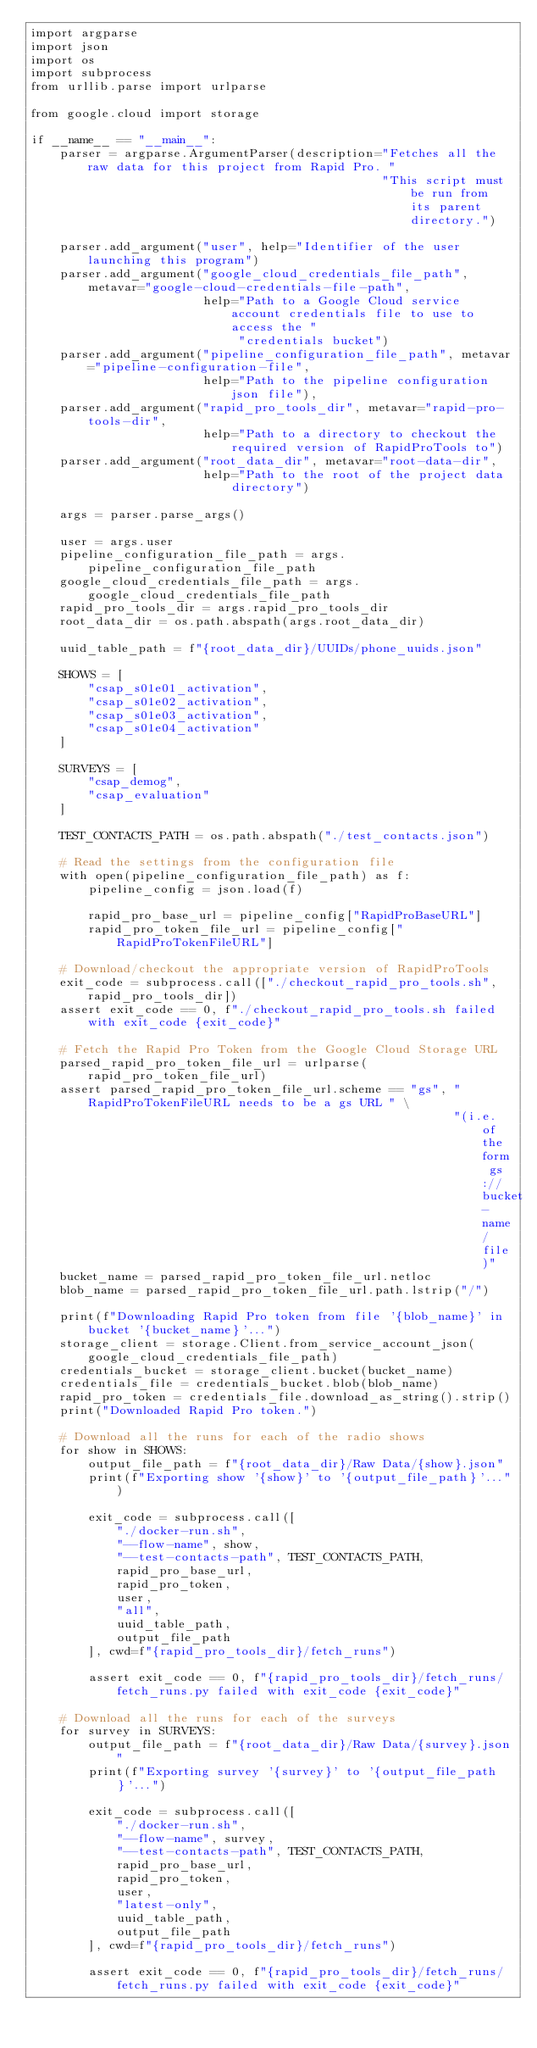Convert code to text. <code><loc_0><loc_0><loc_500><loc_500><_Python_>import argparse
import json
import os
import subprocess
from urllib.parse import urlparse

from google.cloud import storage

if __name__ == "__main__":
    parser = argparse.ArgumentParser(description="Fetches all the raw data for this project from Rapid Pro. "
                                                 "This script must be run from its parent directory.")

    parser.add_argument("user", help="Identifier of the user launching this program")
    parser.add_argument("google_cloud_credentials_file_path", metavar="google-cloud-credentials-file-path",
                        help="Path to a Google Cloud service account credentials file to use to access the "
                             "credentials bucket")
    parser.add_argument("pipeline_configuration_file_path", metavar="pipeline-configuration-file",
                        help="Path to the pipeline configuration json file"),
    parser.add_argument("rapid_pro_tools_dir", metavar="rapid-pro-tools-dir",
                        help="Path to a directory to checkout the required version of RapidProTools to")
    parser.add_argument("root_data_dir", metavar="root-data-dir",
                        help="Path to the root of the project data directory")

    args = parser.parse_args()

    user = args.user
    pipeline_configuration_file_path = args.pipeline_configuration_file_path
    google_cloud_credentials_file_path = args.google_cloud_credentials_file_path
    rapid_pro_tools_dir = args.rapid_pro_tools_dir
    root_data_dir = os.path.abspath(args.root_data_dir)

    uuid_table_path = f"{root_data_dir}/UUIDs/phone_uuids.json"

    SHOWS = [
        "csap_s01e01_activation",
        "csap_s01e02_activation",
        "csap_s01e03_activation",
        "csap_s01e04_activation"
    ]

    SURVEYS = [
        "csap_demog",
        "csap_evaluation"
    ]

    TEST_CONTACTS_PATH = os.path.abspath("./test_contacts.json")

    # Read the settings from the configuration file
    with open(pipeline_configuration_file_path) as f:
        pipeline_config = json.load(f)

        rapid_pro_base_url = pipeline_config["RapidProBaseURL"]
        rapid_pro_token_file_url = pipeline_config["RapidProTokenFileURL"]

    # Download/checkout the appropriate version of RapidProTools
    exit_code = subprocess.call(["./checkout_rapid_pro_tools.sh", rapid_pro_tools_dir])
    assert exit_code == 0, f"./checkout_rapid_pro_tools.sh failed with exit_code {exit_code}"

    # Fetch the Rapid Pro Token from the Google Cloud Storage URL
    parsed_rapid_pro_token_file_url = urlparse(rapid_pro_token_file_url)
    assert parsed_rapid_pro_token_file_url.scheme == "gs", "RapidProTokenFileURL needs to be a gs URL " \
                                                           "(i.e. of the form gs://bucket-name/file)"
    bucket_name = parsed_rapid_pro_token_file_url.netloc
    blob_name = parsed_rapid_pro_token_file_url.path.lstrip("/")

    print(f"Downloading Rapid Pro token from file '{blob_name}' in bucket '{bucket_name}'...")
    storage_client = storage.Client.from_service_account_json(google_cloud_credentials_file_path)
    credentials_bucket = storage_client.bucket(bucket_name)
    credentials_file = credentials_bucket.blob(blob_name)
    rapid_pro_token = credentials_file.download_as_string().strip()
    print("Downloaded Rapid Pro token.")

    # Download all the runs for each of the radio shows
    for show in SHOWS:
        output_file_path = f"{root_data_dir}/Raw Data/{show}.json"
        print(f"Exporting show '{show}' to '{output_file_path}'...")

        exit_code = subprocess.call([
            "./docker-run.sh",
            "--flow-name", show,
            "--test-contacts-path", TEST_CONTACTS_PATH,
            rapid_pro_base_url,
            rapid_pro_token,
            user,
            "all",
            uuid_table_path,
            output_file_path
        ], cwd=f"{rapid_pro_tools_dir}/fetch_runs")

        assert exit_code == 0, f"{rapid_pro_tools_dir}/fetch_runs/fetch_runs.py failed with exit_code {exit_code}"

    # Download all the runs for each of the surveys
    for survey in SURVEYS:
        output_file_path = f"{root_data_dir}/Raw Data/{survey}.json"
        print(f"Exporting survey '{survey}' to '{output_file_path}'...")

        exit_code = subprocess.call([
            "./docker-run.sh",
            "--flow-name", survey,
            "--test-contacts-path", TEST_CONTACTS_PATH,
            rapid_pro_base_url,
            rapid_pro_token,
            user,
            "latest-only",
            uuid_table_path,
            output_file_path
        ], cwd=f"{rapid_pro_tools_dir}/fetch_runs")

        assert exit_code == 0, f"{rapid_pro_tools_dir}/fetch_runs/fetch_runs.py failed with exit_code {exit_code}"
</code> 